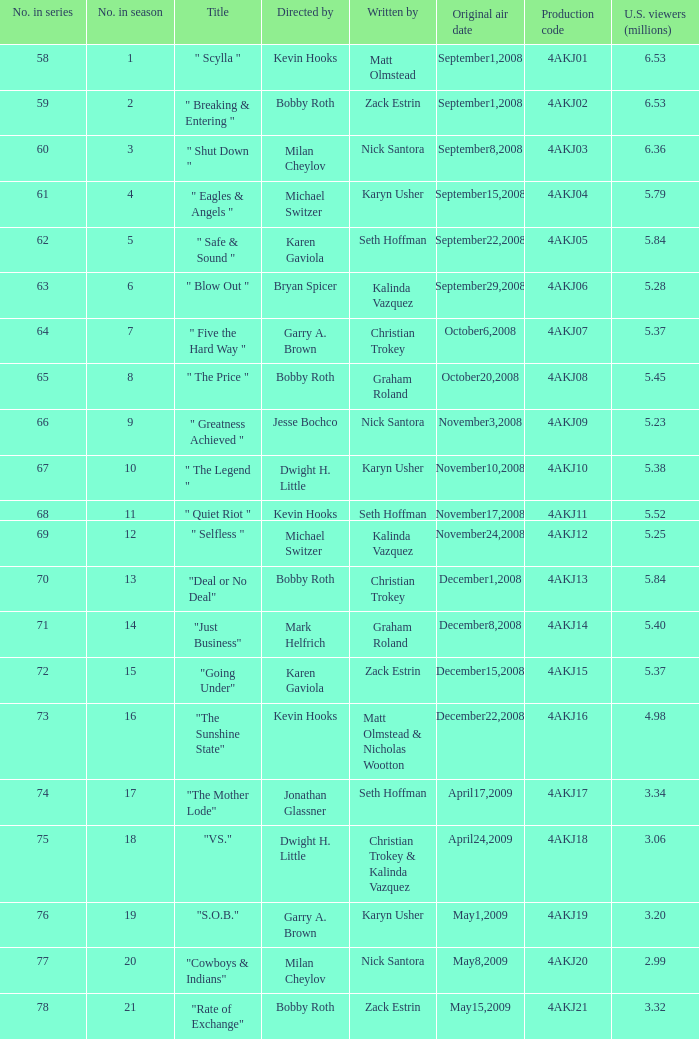Who was the director of the episode with the production code 4akj08? Bobby Roth. 